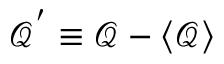<formula> <loc_0><loc_0><loc_500><loc_500>\mathcal { Q } ^ { ^ { \prime } } \equiv \mathcal { Q } - \langle \mathcal { Q } \rangle</formula> 